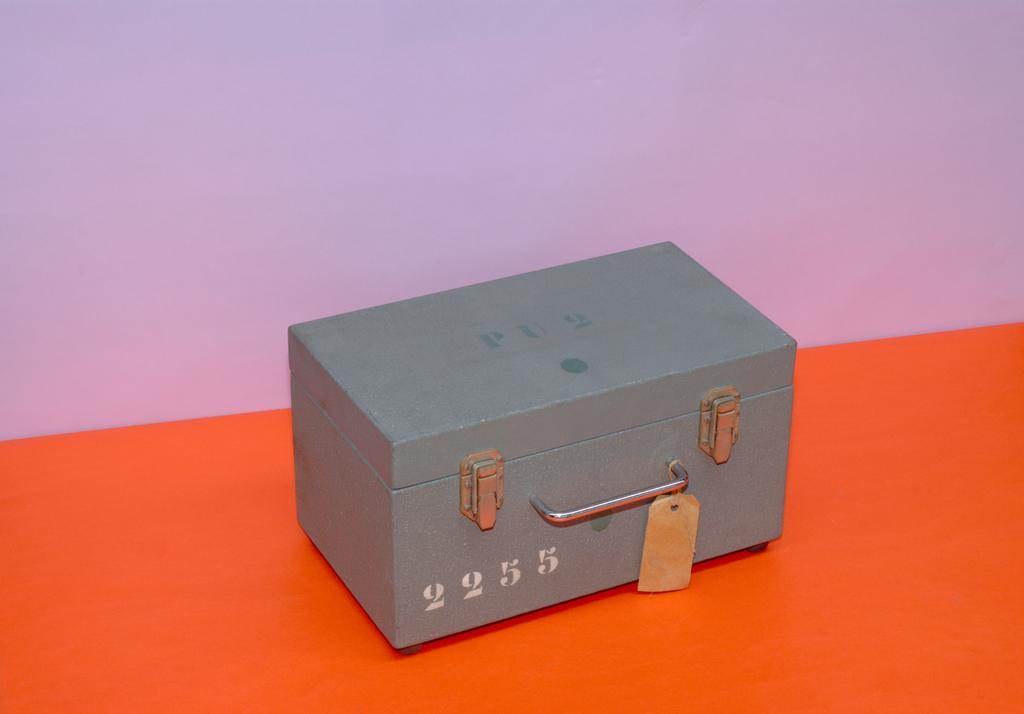<image>
Offer a succinct explanation of the picture presented. A metal box has the number 2255 written in white on its front. 